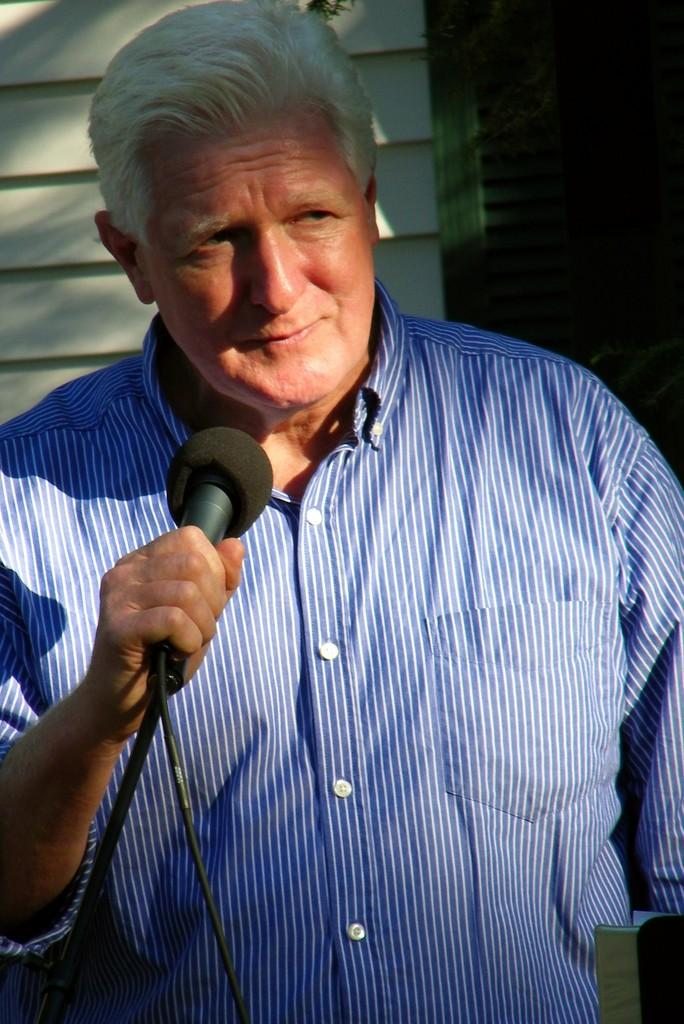What is the main subject of the picture? The main subject of the picture is a man. What is the man holding in his right hand? The man is holding a microphone in his right hand. What expression does the man have on his face? The man is smiling. How many dogs are visible in the picture? There are no dogs present in the picture; it features a man holding a microphone and smiling. What type of insect can be seen crawling on the microphone? There is no insect visible on the microphone in the picture. 